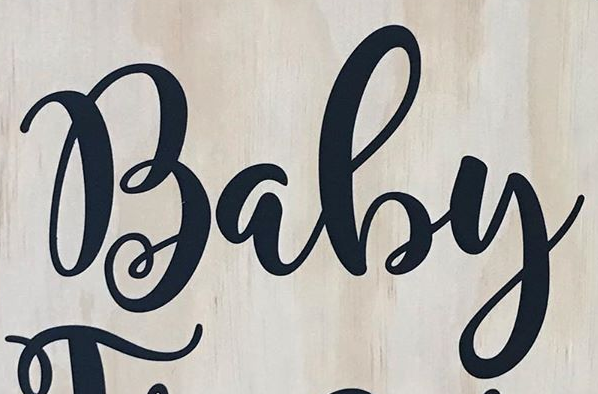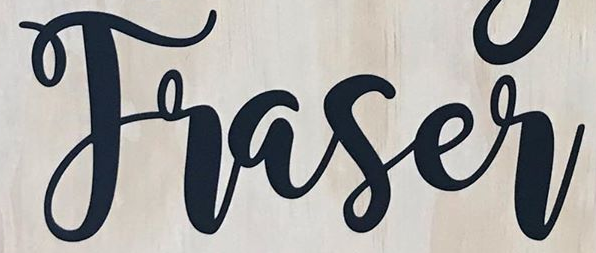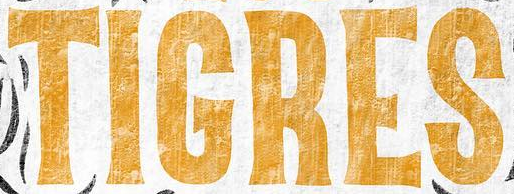What words can you see in these images in sequence, separated by a semicolon? Baby; Traser; TIGRES 